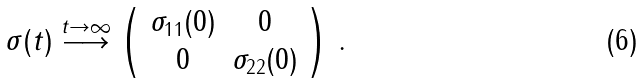<formula> <loc_0><loc_0><loc_500><loc_500>\sigma ( t ) \stackrel { t \to \infty } { \longrightarrow } \left ( \begin{array} { c c } \sigma _ { 1 1 } ( 0 ) & 0 \\ 0 & \sigma _ { 2 2 } ( 0 ) \end{array} \right ) \, .</formula> 